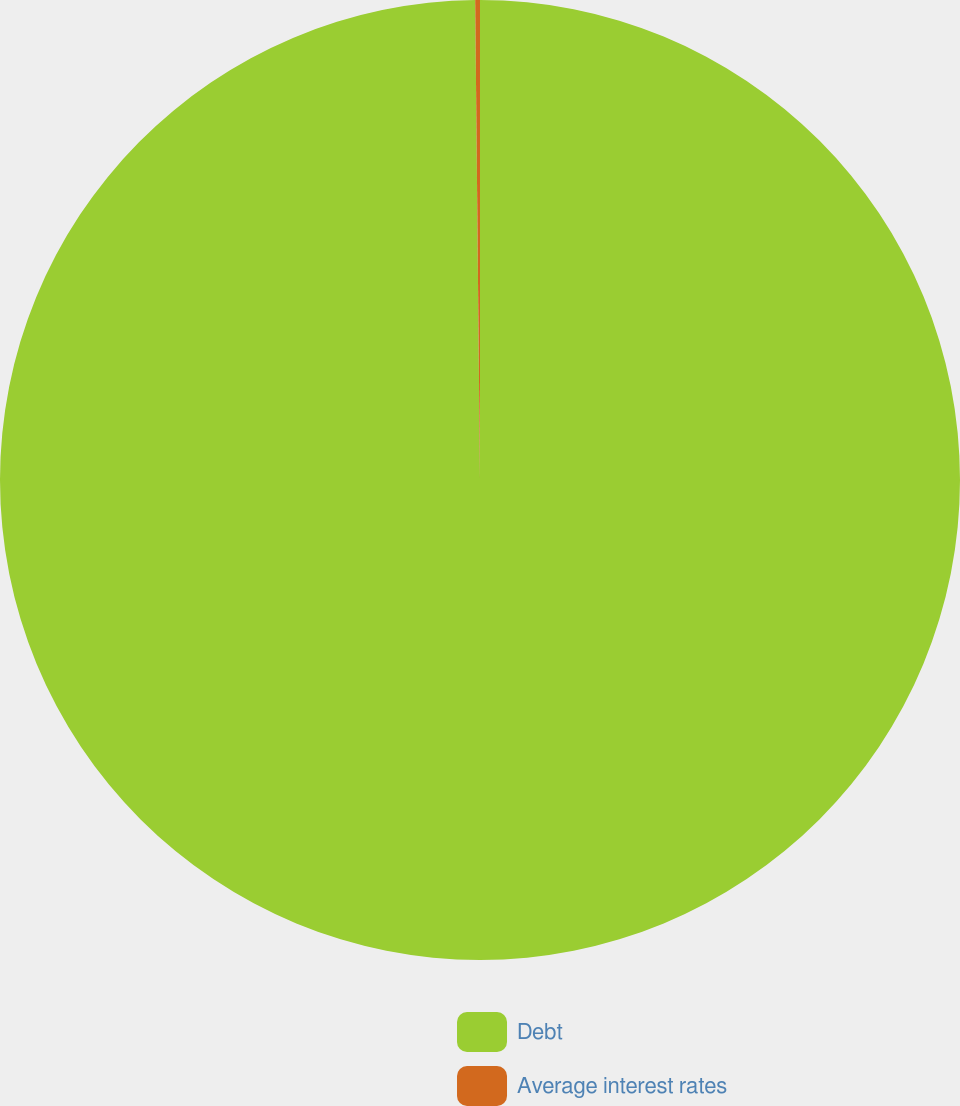<chart> <loc_0><loc_0><loc_500><loc_500><pie_chart><fcel>Debt<fcel>Average interest rates<nl><fcel>99.84%<fcel>0.16%<nl></chart> 